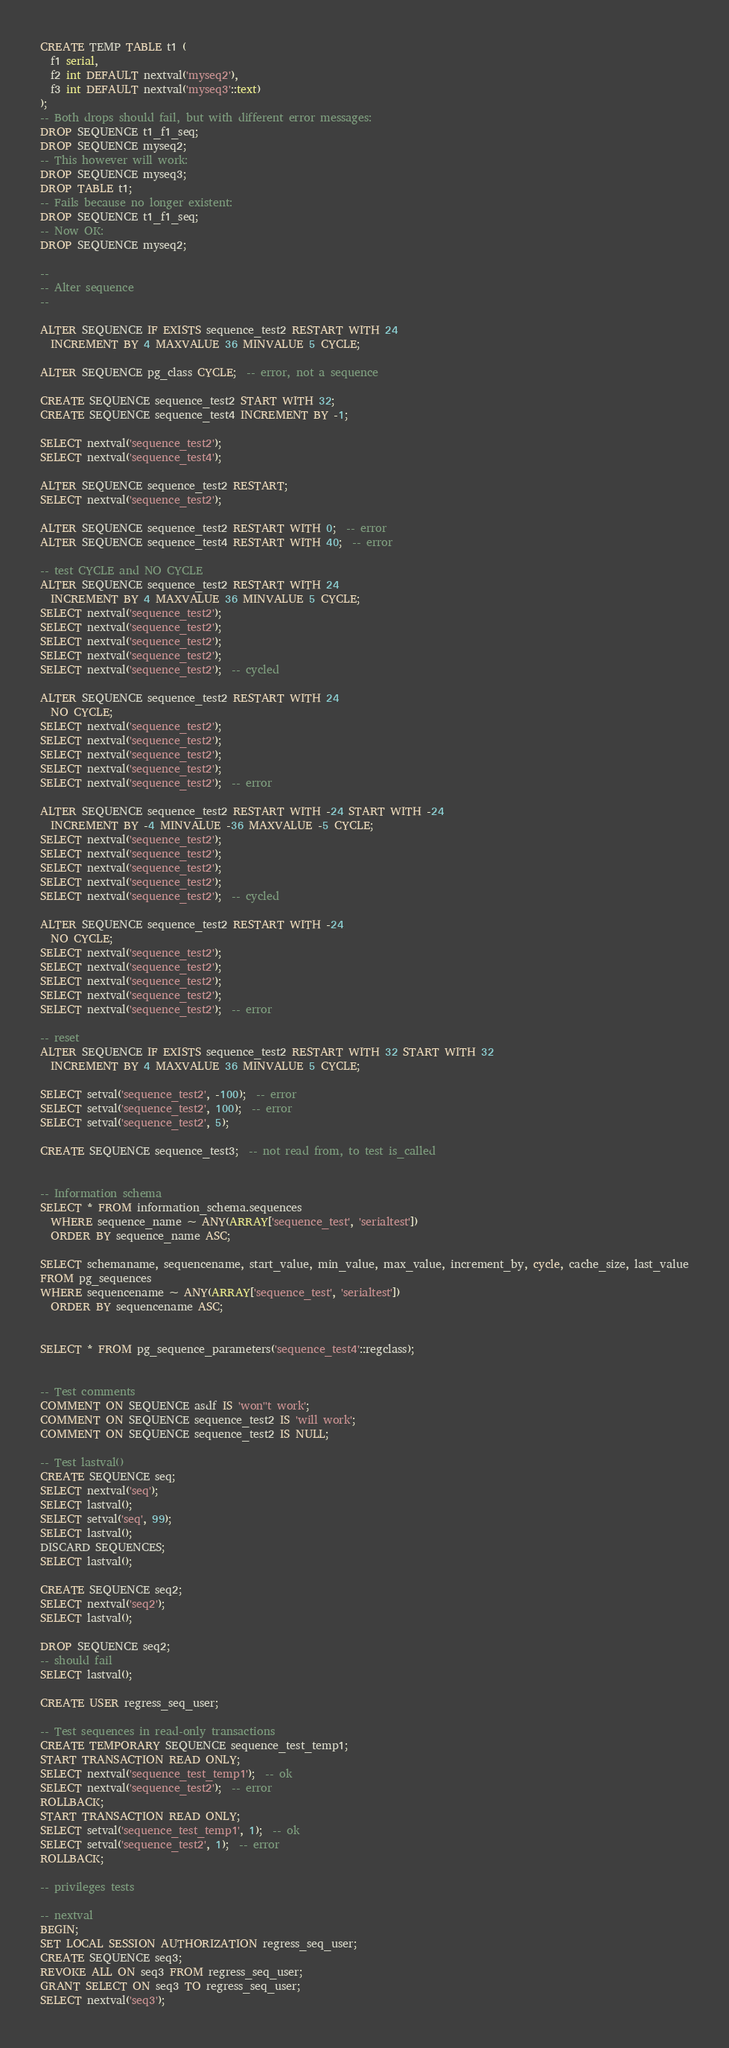<code> <loc_0><loc_0><loc_500><loc_500><_SQL_>CREATE TEMP TABLE t1 (
  f1 serial,
  f2 int DEFAULT nextval('myseq2'),
  f3 int DEFAULT nextval('myseq3'::text)
);
-- Both drops should fail, but with different error messages:
DROP SEQUENCE t1_f1_seq;
DROP SEQUENCE myseq2;
-- This however will work:
DROP SEQUENCE myseq3;
DROP TABLE t1;
-- Fails because no longer existent:
DROP SEQUENCE t1_f1_seq;
-- Now OK:
DROP SEQUENCE myseq2;

--
-- Alter sequence
--

ALTER SEQUENCE IF EXISTS sequence_test2 RESTART WITH 24
  INCREMENT BY 4 MAXVALUE 36 MINVALUE 5 CYCLE;

ALTER SEQUENCE pg_class CYCLE;  -- error, not a sequence

CREATE SEQUENCE sequence_test2 START WITH 32;
CREATE SEQUENCE sequence_test4 INCREMENT BY -1;

SELECT nextval('sequence_test2');
SELECT nextval('sequence_test4');

ALTER SEQUENCE sequence_test2 RESTART;
SELECT nextval('sequence_test2');

ALTER SEQUENCE sequence_test2 RESTART WITH 0;  -- error
ALTER SEQUENCE sequence_test4 RESTART WITH 40;  -- error

-- test CYCLE and NO CYCLE
ALTER SEQUENCE sequence_test2 RESTART WITH 24
  INCREMENT BY 4 MAXVALUE 36 MINVALUE 5 CYCLE;
SELECT nextval('sequence_test2');
SELECT nextval('sequence_test2');
SELECT nextval('sequence_test2');
SELECT nextval('sequence_test2');
SELECT nextval('sequence_test2');  -- cycled

ALTER SEQUENCE sequence_test2 RESTART WITH 24
  NO CYCLE;
SELECT nextval('sequence_test2');
SELECT nextval('sequence_test2');
SELECT nextval('sequence_test2');
SELECT nextval('sequence_test2');
SELECT nextval('sequence_test2');  -- error

ALTER SEQUENCE sequence_test2 RESTART WITH -24 START WITH -24
  INCREMENT BY -4 MINVALUE -36 MAXVALUE -5 CYCLE;
SELECT nextval('sequence_test2');
SELECT nextval('sequence_test2');
SELECT nextval('sequence_test2');
SELECT nextval('sequence_test2');
SELECT nextval('sequence_test2');  -- cycled

ALTER SEQUENCE sequence_test2 RESTART WITH -24
  NO CYCLE;
SELECT nextval('sequence_test2');
SELECT nextval('sequence_test2');
SELECT nextval('sequence_test2');
SELECT nextval('sequence_test2');
SELECT nextval('sequence_test2');  -- error

-- reset
ALTER SEQUENCE IF EXISTS sequence_test2 RESTART WITH 32 START WITH 32
  INCREMENT BY 4 MAXVALUE 36 MINVALUE 5 CYCLE;

SELECT setval('sequence_test2', -100);  -- error
SELECT setval('sequence_test2', 100);  -- error
SELECT setval('sequence_test2', 5);

CREATE SEQUENCE sequence_test3;  -- not read from, to test is_called


-- Information schema
SELECT * FROM information_schema.sequences
  WHERE sequence_name ~ ANY(ARRAY['sequence_test', 'serialtest'])
  ORDER BY sequence_name ASC;

SELECT schemaname, sequencename, start_value, min_value, max_value, increment_by, cycle, cache_size, last_value
FROM pg_sequences
WHERE sequencename ~ ANY(ARRAY['sequence_test', 'serialtest'])
  ORDER BY sequencename ASC;


SELECT * FROM pg_sequence_parameters('sequence_test4'::regclass);


-- Test comments
COMMENT ON SEQUENCE asdf IS 'won''t work';
COMMENT ON SEQUENCE sequence_test2 IS 'will work';
COMMENT ON SEQUENCE sequence_test2 IS NULL;

-- Test lastval()
CREATE SEQUENCE seq;
SELECT nextval('seq');
SELECT lastval();
SELECT setval('seq', 99);
SELECT lastval();
DISCARD SEQUENCES;
SELECT lastval();

CREATE SEQUENCE seq2;
SELECT nextval('seq2');
SELECT lastval();

DROP SEQUENCE seq2;
-- should fail
SELECT lastval();

CREATE USER regress_seq_user;

-- Test sequences in read-only transactions
CREATE TEMPORARY SEQUENCE sequence_test_temp1;
START TRANSACTION READ ONLY;
SELECT nextval('sequence_test_temp1');  -- ok
SELECT nextval('sequence_test2');  -- error
ROLLBACK;
START TRANSACTION READ ONLY;
SELECT setval('sequence_test_temp1', 1);  -- ok
SELECT setval('sequence_test2', 1);  -- error
ROLLBACK;

-- privileges tests

-- nextval
BEGIN;
SET LOCAL SESSION AUTHORIZATION regress_seq_user;
CREATE SEQUENCE seq3;
REVOKE ALL ON seq3 FROM regress_seq_user;
GRANT SELECT ON seq3 TO regress_seq_user;
SELECT nextval('seq3');</code> 